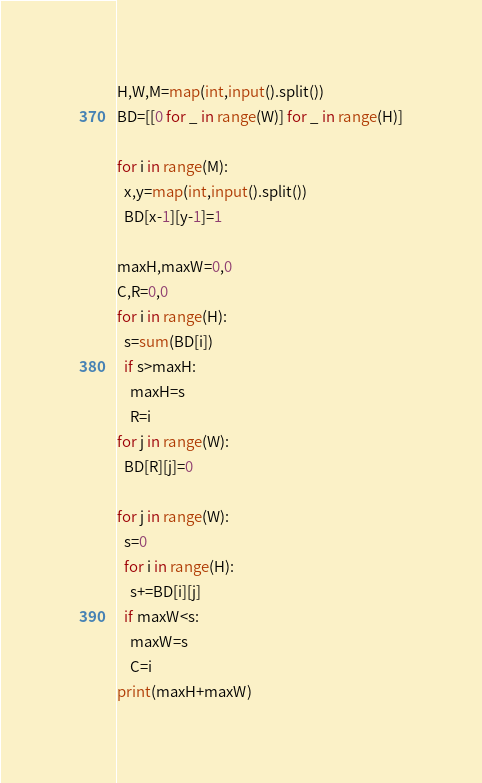Convert code to text. <code><loc_0><loc_0><loc_500><loc_500><_Python_>H,W,M=map(int,input().split())
BD=[[0 for _ in range(W)] for _ in range(H)]

for i in range(M):
  x,y=map(int,input().split())
  BD[x-1][y-1]=1

maxH,maxW=0,0
C,R=0,0
for i in range(H):
  s=sum(BD[i])
  if s>maxH:
    maxH=s
    R=i
for j in range(W):
  BD[R][j]=0

for j in range(W):
  s=0
  for i in range(H):
    s+=BD[i][j]
  if maxW<s:
    maxW=s
    C=i
print(maxH+maxW)
</code> 